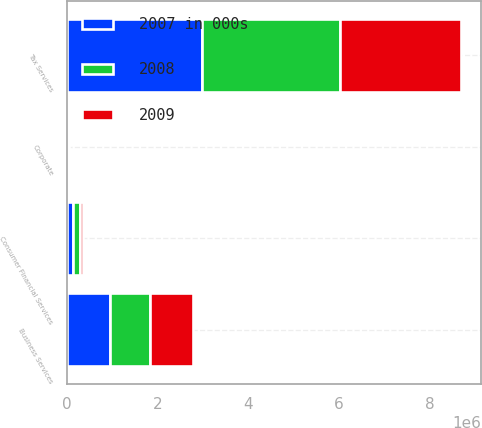<chart> <loc_0><loc_0><loc_500><loc_500><stacked_bar_chart><ecel><fcel>Tax Services<fcel>Business Services<fcel>Consumer Financial Services<fcel>Corporate<nl><fcel>2008<fcel>3.03312e+06<fcel>897809<fcel>141801<fcel>10844<nl><fcel>2007 in 000s<fcel>2.98862e+06<fcel>941686<fcel>142706<fcel>13621<nl><fcel>2009<fcel>2.68586e+06<fcel>932361<fcel>77178<fcel>14965<nl></chart> 